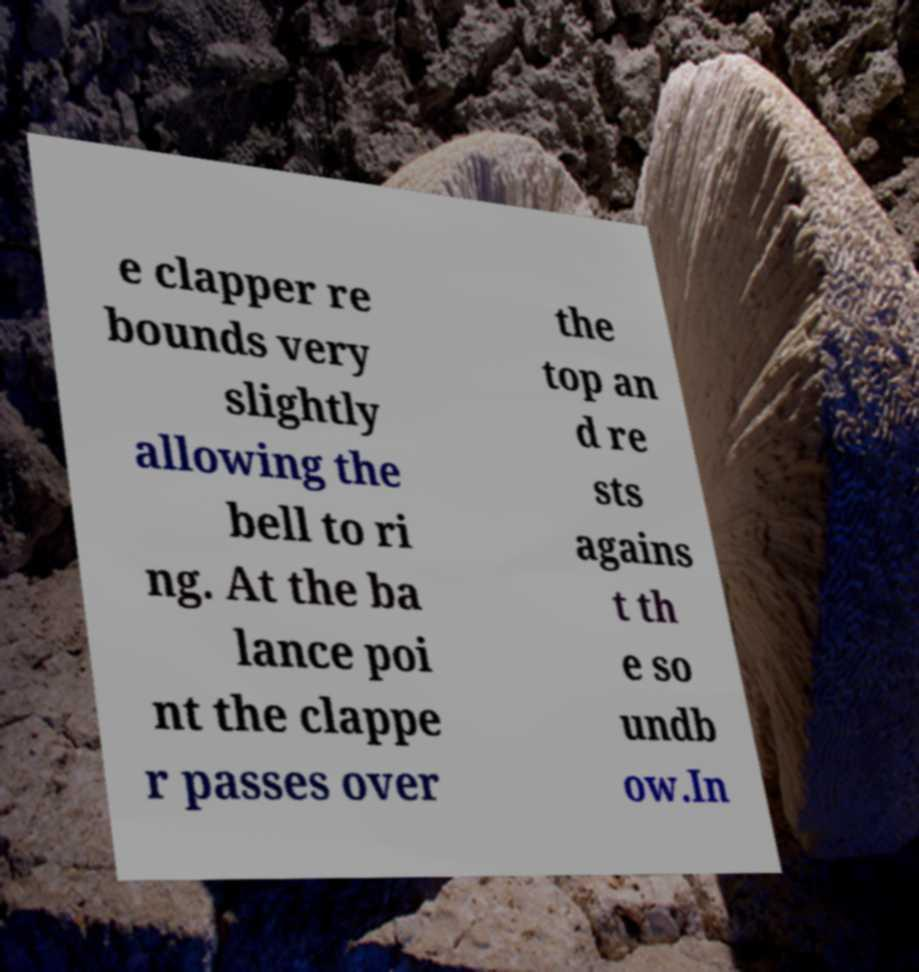Please identify and transcribe the text found in this image. e clapper re bounds very slightly allowing the bell to ri ng. At the ba lance poi nt the clappe r passes over the top an d re sts agains t th e so undb ow.In 